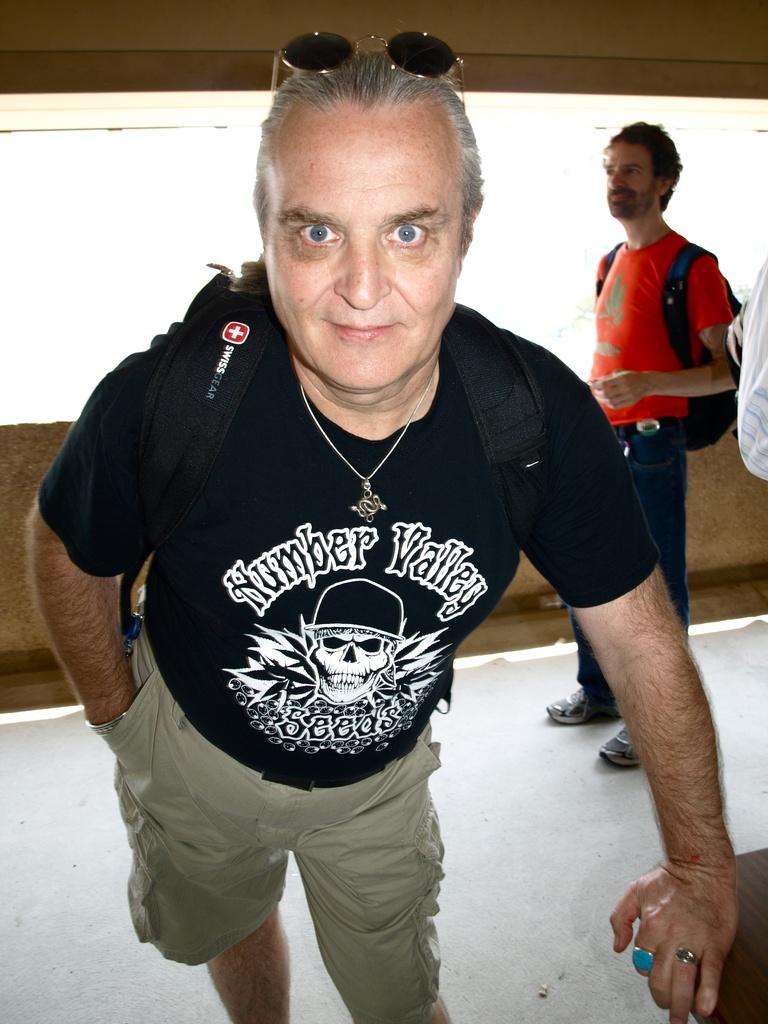Provide a one-sentence caption for the provided image. An older man with glasses on his head and a black tee shirt with the words Number Valley written on it. 